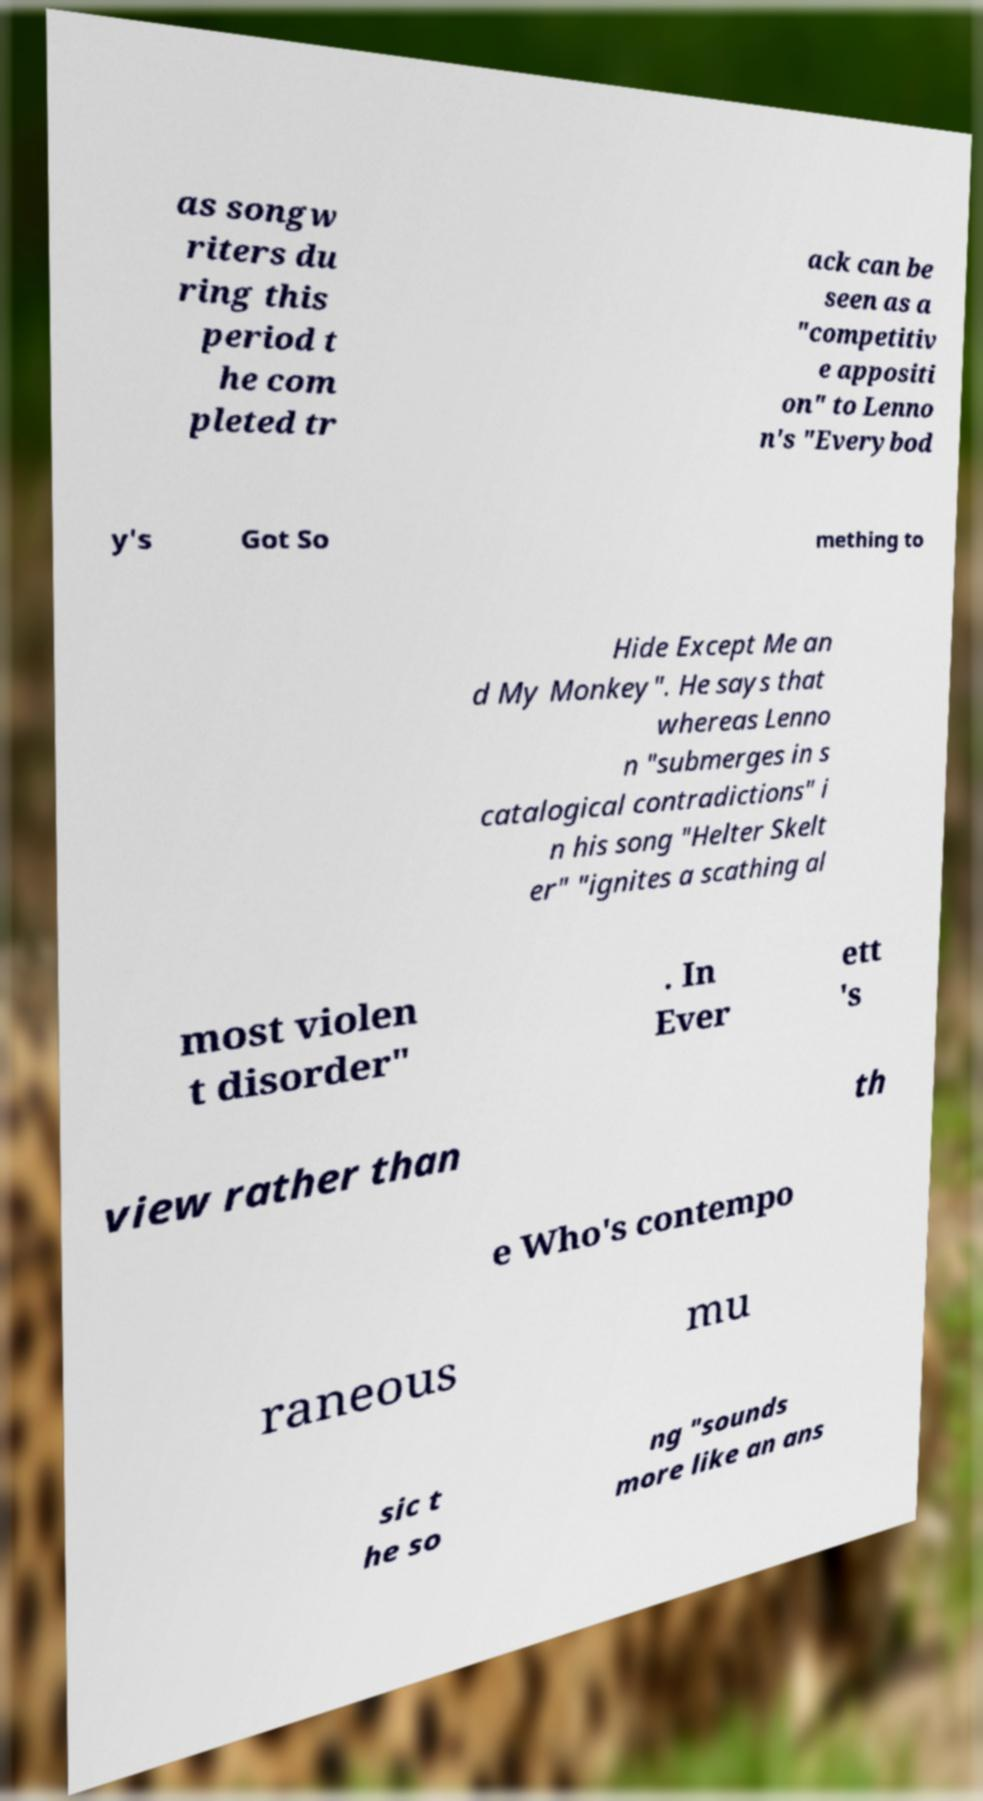For documentation purposes, I need the text within this image transcribed. Could you provide that? as songw riters du ring this period t he com pleted tr ack can be seen as a "competitiv e appositi on" to Lenno n's "Everybod y's Got So mething to Hide Except Me an d My Monkey". He says that whereas Lenno n "submerges in s catalogical contradictions" i n his song "Helter Skelt er" "ignites a scathing al most violen t disorder" . In Ever ett 's view rather than th e Who's contempo raneous mu sic t he so ng "sounds more like an ans 